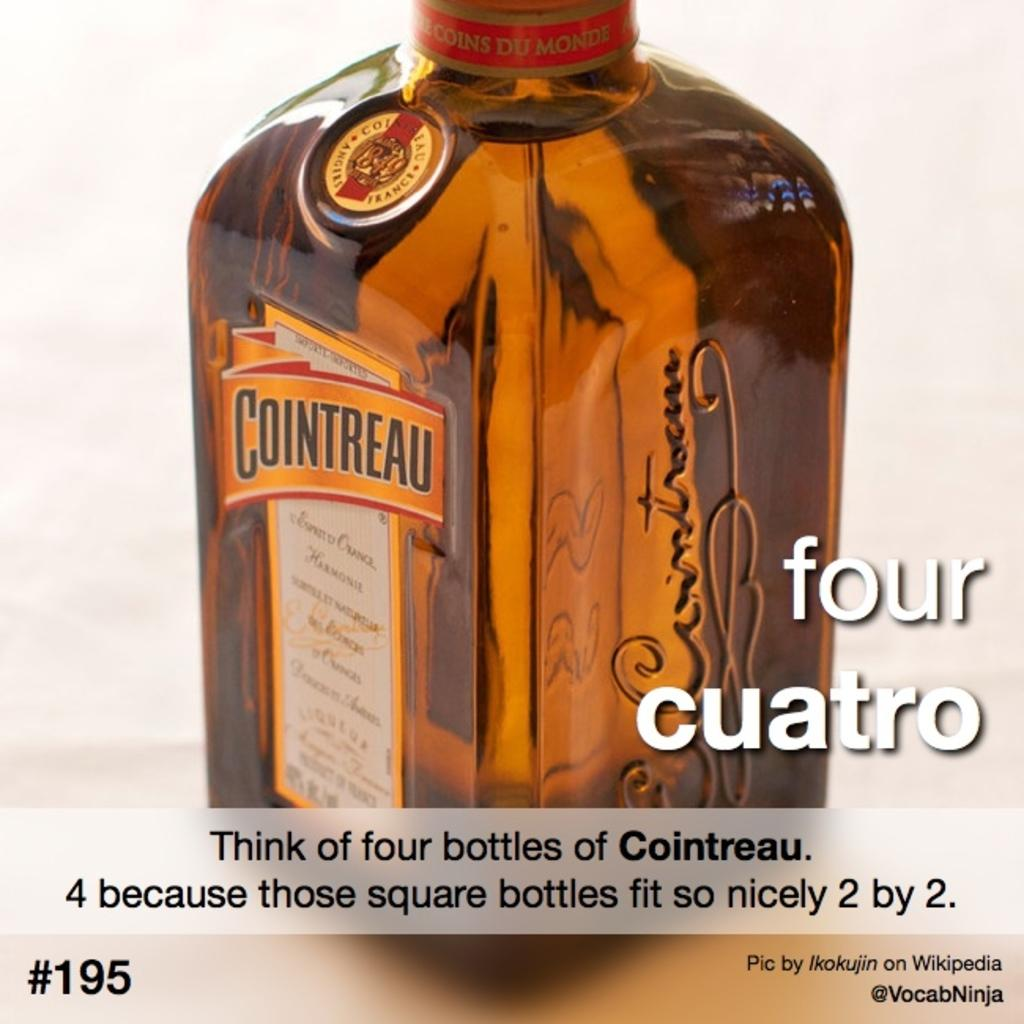<image>
Offer a succinct explanation of the picture presented. A bottle of orange flavored Cointreau liquor sits on a table. 